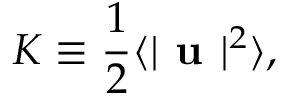Convert formula to latex. <formula><loc_0><loc_0><loc_500><loc_500>K \equiv \frac { 1 } { 2 } \langle | u | ^ { 2 } \rangle ,</formula> 